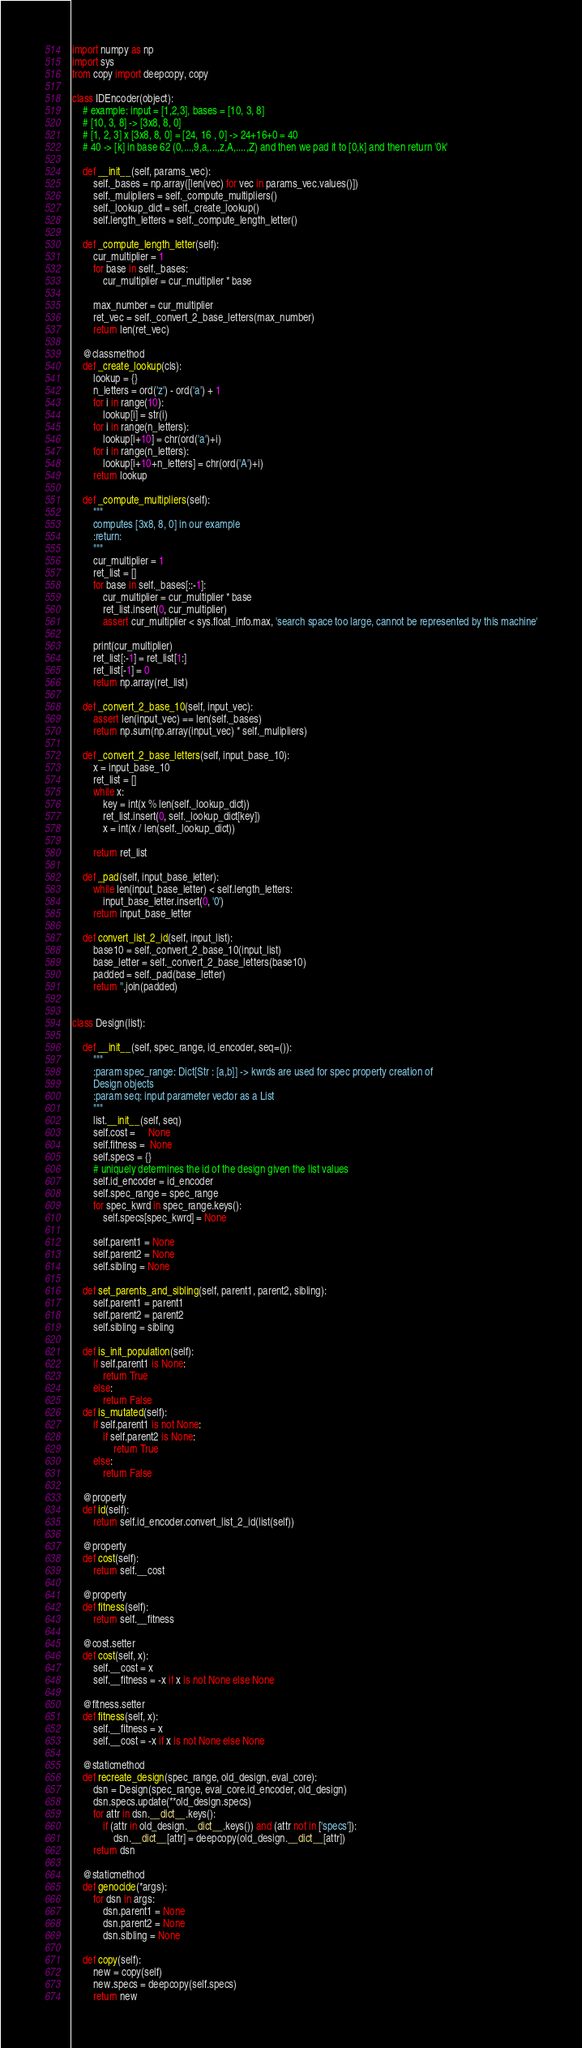Convert code to text. <code><loc_0><loc_0><loc_500><loc_500><_Python_>import numpy as np
import sys
from copy import deepcopy, copy

class IDEncoder(object):
    # example: input = [1,2,3], bases = [10, 3, 8]
    # [10, 3, 8] -> [3x8, 8, 0]
    # [1, 2, 3] x [3x8, 8, 0] = [24, 16 , 0] -> 24+16+0 = 40
    # 40 -> [k] in base 62 (0,...,9,a,...,z,A,....,Z) and then we pad it to [0,k] and then return '0k'

    def __init__(self, params_vec):
        self._bases = np.array([len(vec) for vec in params_vec.values()])
        self._mulipliers = self._compute_multipliers()
        self._lookup_dict = self._create_lookup()
        self.length_letters = self._compute_length_letter()

    def _compute_length_letter(self):
        cur_multiplier = 1
        for base in self._bases:
            cur_multiplier = cur_multiplier * base

        max_number = cur_multiplier
        ret_vec = self._convert_2_base_letters(max_number)
        return len(ret_vec)

    @classmethod
    def _create_lookup(cls):
        lookup = {}
        n_letters = ord('z') - ord('a') + 1
        for i in range(10):
            lookup[i] = str(i)
        for i in range(n_letters):
            lookup[i+10] = chr(ord('a')+i)
        for i in range(n_letters):
            lookup[i+10+n_letters] = chr(ord('A')+i)
        return lookup

    def _compute_multipliers(self):
        """
        computes [3x8, 8, 0] in our example
        :return:
        """
        cur_multiplier = 1
        ret_list = []
        for base in self._bases[::-1]:
            cur_multiplier = cur_multiplier * base
            ret_list.insert(0, cur_multiplier)
            assert cur_multiplier < sys.float_info.max, 'search space too large, cannot be represented by this machine'

        print(cur_multiplier)
        ret_list[:-1] = ret_list[1:]
        ret_list[-1] = 0
        return np.array(ret_list)

    def _convert_2_base_10(self, input_vec):
        assert len(input_vec) == len(self._bases)
        return np.sum(np.array(input_vec) * self._mulipliers)

    def _convert_2_base_letters(self, input_base_10):
        x = input_base_10
        ret_list = []
        while x:
            key = int(x % len(self._lookup_dict))
            ret_list.insert(0, self._lookup_dict[key])
            x = int(x / len(self._lookup_dict))

        return ret_list

    def _pad(self, input_base_letter):
        while len(input_base_letter) < self.length_letters:
            input_base_letter.insert(0, '0')
        return input_base_letter

    def convert_list_2_id(self, input_list):
        base10 = self._convert_2_base_10(input_list)
        base_letter = self._convert_2_base_letters(base10)
        padded = self._pad(base_letter)
        return ''.join(padded)


class Design(list):

    def __init__(self, spec_range, id_encoder, seq=()):
        """
        :param spec_range: Dict[Str : [a,b]] -> kwrds are used for spec property creation of
        Design objects
        :param seq: input parameter vector as a List
        """
        list.__init__(self, seq)
        self.cost =     None
        self.fitness =  None
        self.specs = {}
        # uniquely determines the id of the design given the list values
        self.id_encoder = id_encoder
        self.spec_range = spec_range
        for spec_kwrd in spec_range.keys():
            self.specs[spec_kwrd] = None

        self.parent1 = None
        self.parent2 = None
        self.sibling = None

    def set_parents_and_sibling(self, parent1, parent2, sibling):
        self.parent1 = parent1
        self.parent2 = parent2
        self.sibling = sibling

    def is_init_population(self):
        if self.parent1 is None:
            return True
        else:
            return False
    def is_mutated(self):
        if self.parent1 is not None:
            if self.parent2 is None:
                return True
        else:
            return False

    @property
    def id(self):
        return self.id_encoder.convert_list_2_id(list(self))

    @property
    def cost(self):
        return self.__cost

    @property
    def fitness(self):
        return self.__fitness

    @cost.setter
    def cost(self, x):
        self.__cost = x
        self.__fitness = -x if x is not None else None

    @fitness.setter
    def fitness(self, x):
        self.__fitness = x
        self.__cost = -x if x is not None else None

    @staticmethod
    def recreate_design(spec_range, old_design, eval_core):
        dsn = Design(spec_range, eval_core.id_encoder, old_design)
        dsn.specs.update(**old_design.specs)
        for attr in dsn.__dict__.keys():
            if (attr in old_design.__dict__.keys()) and (attr not in ['specs']):
                dsn.__dict__[attr] = deepcopy(old_design.__dict__[attr])
        return dsn

    @staticmethod
    def genocide(*args):
        for dsn in args:
            dsn.parent1 = None
            dsn.parent2 = None
            dsn.sibling = None

    def copy(self):
        new = copy(self)
        new.specs = deepcopy(self.specs)
        return new</code> 